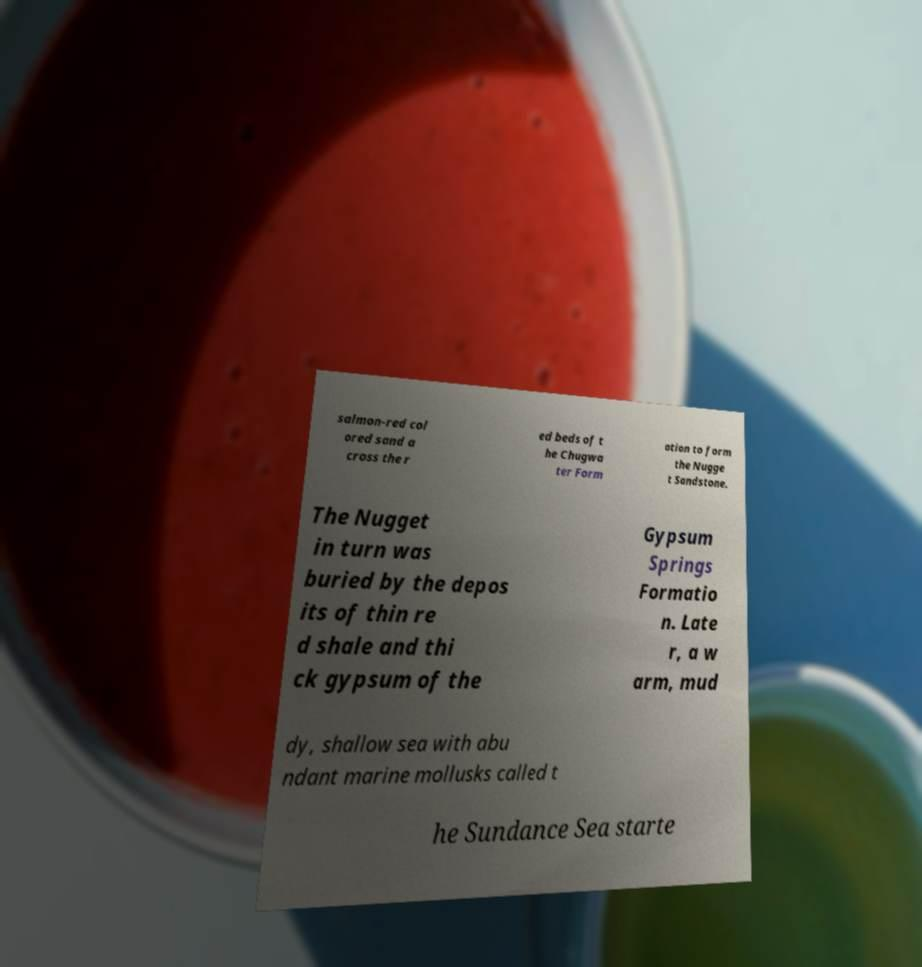Please read and relay the text visible in this image. What does it say? salmon-red col ored sand a cross the r ed beds of t he Chugwa ter Form ation to form the Nugge t Sandstone. The Nugget in turn was buried by the depos its of thin re d shale and thi ck gypsum of the Gypsum Springs Formatio n. Late r, a w arm, mud dy, shallow sea with abu ndant marine mollusks called t he Sundance Sea starte 